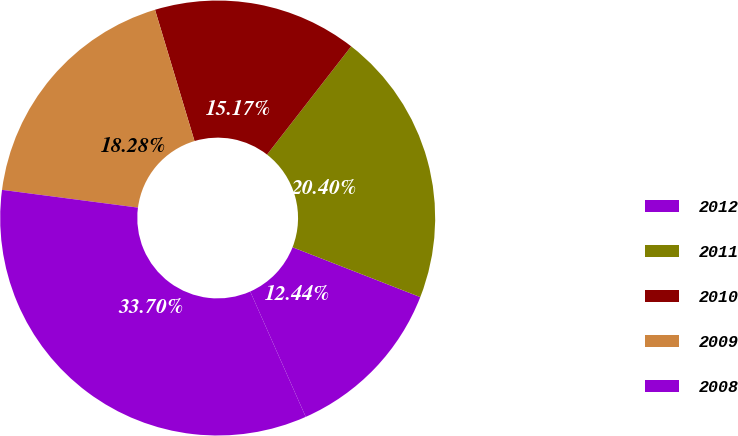<chart> <loc_0><loc_0><loc_500><loc_500><pie_chart><fcel>2012<fcel>2011<fcel>2010<fcel>2009<fcel>2008<nl><fcel>12.44%<fcel>20.4%<fcel>15.17%<fcel>18.28%<fcel>33.7%<nl></chart> 